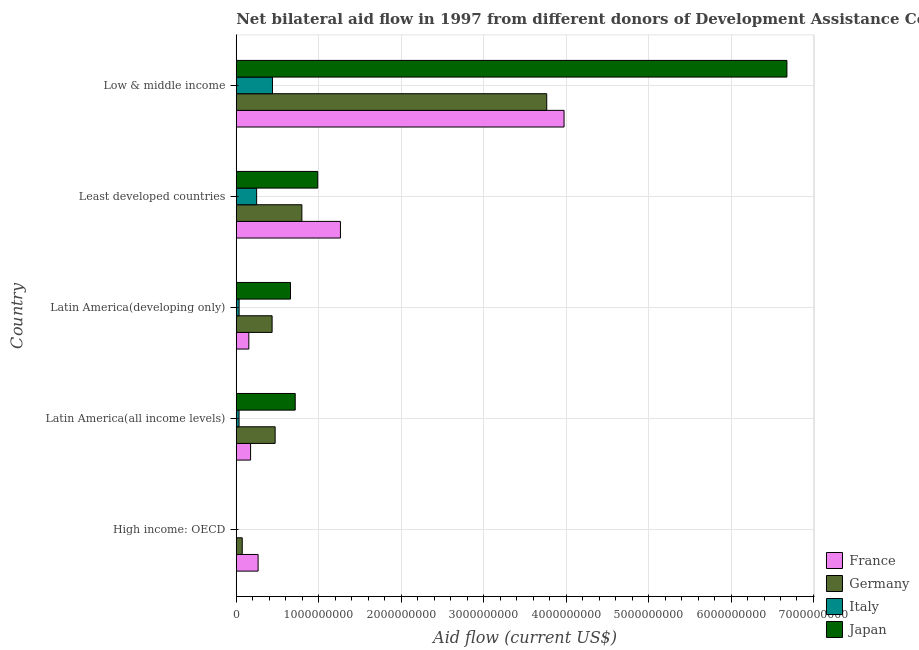How many groups of bars are there?
Keep it short and to the point. 5. Are the number of bars per tick equal to the number of legend labels?
Provide a succinct answer. No. How many bars are there on the 3rd tick from the top?
Give a very brief answer. 4. How many bars are there on the 2nd tick from the bottom?
Your answer should be compact. 4. What is the label of the 4th group of bars from the top?
Offer a very short reply. Latin America(all income levels). In how many cases, is the number of bars for a given country not equal to the number of legend labels?
Provide a short and direct response. 1. What is the amount of aid given by germany in Latin America(all income levels)?
Your response must be concise. 4.72e+08. Across all countries, what is the maximum amount of aid given by japan?
Provide a succinct answer. 6.68e+09. In which country was the amount of aid given by france maximum?
Your answer should be compact. Low & middle income. What is the total amount of aid given by france in the graph?
Provide a succinct answer. 5.83e+09. What is the difference between the amount of aid given by japan in Latin America(developing only) and that in Low & middle income?
Make the answer very short. -6.02e+09. What is the difference between the amount of aid given by france in Least developed countries and the amount of aid given by italy in High income: OECD?
Provide a succinct answer. 1.26e+09. What is the average amount of aid given by italy per country?
Your answer should be compact. 1.51e+08. What is the difference between the amount of aid given by italy and amount of aid given by japan in Latin America(all income levels)?
Offer a terse response. -6.81e+08. In how many countries, is the amount of aid given by germany greater than 5600000000 US$?
Your answer should be very brief. 0. What is the ratio of the amount of aid given by italy in Latin America(all income levels) to that in Low & middle income?
Provide a succinct answer. 0.08. Is the amount of aid given by france in Least developed countries less than that in Low & middle income?
Offer a terse response. Yes. Is the difference between the amount of aid given by japan in Least developed countries and Low & middle income greater than the difference between the amount of aid given by france in Least developed countries and Low & middle income?
Your answer should be very brief. No. What is the difference between the highest and the second highest amount of aid given by germany?
Your answer should be compact. 2.97e+09. What is the difference between the highest and the lowest amount of aid given by japan?
Ensure brevity in your answer.  6.68e+09. Is the sum of the amount of aid given by germany in Least developed countries and Low & middle income greater than the maximum amount of aid given by japan across all countries?
Make the answer very short. No. What is the difference between two consecutive major ticks on the X-axis?
Keep it short and to the point. 1.00e+09. Are the values on the major ticks of X-axis written in scientific E-notation?
Give a very brief answer. No. How are the legend labels stacked?
Make the answer very short. Vertical. What is the title of the graph?
Offer a terse response. Net bilateral aid flow in 1997 from different donors of Development Assistance Committee. What is the label or title of the Y-axis?
Provide a succinct answer. Country. What is the Aid flow (current US$) in France in High income: OECD?
Your answer should be very brief. 2.65e+08. What is the Aid flow (current US$) of Germany in High income: OECD?
Provide a succinct answer. 7.26e+07. What is the Aid flow (current US$) in Italy in High income: OECD?
Give a very brief answer. 1.71e+06. What is the Aid flow (current US$) of France in Latin America(all income levels)?
Your answer should be very brief. 1.74e+08. What is the Aid flow (current US$) of Germany in Latin America(all income levels)?
Provide a succinct answer. 4.72e+08. What is the Aid flow (current US$) of Italy in Latin America(all income levels)?
Offer a terse response. 3.40e+07. What is the Aid flow (current US$) in Japan in Latin America(all income levels)?
Ensure brevity in your answer.  7.15e+08. What is the Aid flow (current US$) in France in Latin America(developing only)?
Offer a very short reply. 1.52e+08. What is the Aid flow (current US$) in Germany in Latin America(developing only)?
Make the answer very short. 4.35e+08. What is the Aid flow (current US$) in Italy in Latin America(developing only)?
Your response must be concise. 3.46e+07. What is the Aid flow (current US$) in Japan in Latin America(developing only)?
Provide a short and direct response. 6.58e+08. What is the Aid flow (current US$) of France in Least developed countries?
Your answer should be compact. 1.26e+09. What is the Aid flow (current US$) of Germany in Least developed countries?
Make the answer very short. 7.96e+08. What is the Aid flow (current US$) of Italy in Least developed countries?
Offer a very short reply. 2.47e+08. What is the Aid flow (current US$) of Japan in Least developed countries?
Your answer should be compact. 9.88e+08. What is the Aid flow (current US$) in France in Low & middle income?
Offer a very short reply. 3.98e+09. What is the Aid flow (current US$) in Germany in Low & middle income?
Your response must be concise. 3.77e+09. What is the Aid flow (current US$) in Italy in Low & middle income?
Your response must be concise. 4.39e+08. What is the Aid flow (current US$) of Japan in Low & middle income?
Offer a very short reply. 6.68e+09. Across all countries, what is the maximum Aid flow (current US$) in France?
Offer a terse response. 3.98e+09. Across all countries, what is the maximum Aid flow (current US$) in Germany?
Ensure brevity in your answer.  3.77e+09. Across all countries, what is the maximum Aid flow (current US$) of Italy?
Provide a succinct answer. 4.39e+08. Across all countries, what is the maximum Aid flow (current US$) of Japan?
Provide a succinct answer. 6.68e+09. Across all countries, what is the minimum Aid flow (current US$) in France?
Your answer should be compact. 1.52e+08. Across all countries, what is the minimum Aid flow (current US$) of Germany?
Provide a short and direct response. 7.26e+07. Across all countries, what is the minimum Aid flow (current US$) in Italy?
Ensure brevity in your answer.  1.71e+06. Across all countries, what is the minimum Aid flow (current US$) in Japan?
Give a very brief answer. 0. What is the total Aid flow (current US$) of France in the graph?
Your response must be concise. 5.83e+09. What is the total Aid flow (current US$) in Germany in the graph?
Your response must be concise. 5.54e+09. What is the total Aid flow (current US$) of Italy in the graph?
Offer a very short reply. 7.57e+08. What is the total Aid flow (current US$) of Japan in the graph?
Provide a succinct answer. 9.04e+09. What is the difference between the Aid flow (current US$) in France in High income: OECD and that in Latin America(all income levels)?
Provide a succinct answer. 9.13e+07. What is the difference between the Aid flow (current US$) in Germany in High income: OECD and that in Latin America(all income levels)?
Make the answer very short. -3.99e+08. What is the difference between the Aid flow (current US$) of Italy in High income: OECD and that in Latin America(all income levels)?
Offer a terse response. -3.23e+07. What is the difference between the Aid flow (current US$) in France in High income: OECD and that in Latin America(developing only)?
Provide a short and direct response. 1.13e+08. What is the difference between the Aid flow (current US$) of Germany in High income: OECD and that in Latin America(developing only)?
Offer a terse response. -3.62e+08. What is the difference between the Aid flow (current US$) of Italy in High income: OECD and that in Latin America(developing only)?
Ensure brevity in your answer.  -3.29e+07. What is the difference between the Aid flow (current US$) of France in High income: OECD and that in Least developed countries?
Keep it short and to the point. -9.99e+08. What is the difference between the Aid flow (current US$) in Germany in High income: OECD and that in Least developed countries?
Give a very brief answer. -7.23e+08. What is the difference between the Aid flow (current US$) of Italy in High income: OECD and that in Least developed countries?
Offer a terse response. -2.46e+08. What is the difference between the Aid flow (current US$) in France in High income: OECD and that in Low & middle income?
Your answer should be compact. -3.71e+09. What is the difference between the Aid flow (current US$) of Germany in High income: OECD and that in Low & middle income?
Give a very brief answer. -3.69e+09. What is the difference between the Aid flow (current US$) of Italy in High income: OECD and that in Low & middle income?
Provide a succinct answer. -4.38e+08. What is the difference between the Aid flow (current US$) of France in Latin America(all income levels) and that in Latin America(developing only)?
Ensure brevity in your answer.  2.13e+07. What is the difference between the Aid flow (current US$) in Germany in Latin America(all income levels) and that in Latin America(developing only)?
Give a very brief answer. 3.68e+07. What is the difference between the Aid flow (current US$) of Italy in Latin America(all income levels) and that in Latin America(developing only)?
Offer a very short reply. -6.20e+05. What is the difference between the Aid flow (current US$) in Japan in Latin America(all income levels) and that in Latin America(developing only)?
Provide a short and direct response. 5.74e+07. What is the difference between the Aid flow (current US$) in France in Latin America(all income levels) and that in Least developed countries?
Provide a short and direct response. -1.09e+09. What is the difference between the Aid flow (current US$) in Germany in Latin America(all income levels) and that in Least developed countries?
Your response must be concise. -3.24e+08. What is the difference between the Aid flow (current US$) of Italy in Latin America(all income levels) and that in Least developed countries?
Keep it short and to the point. -2.13e+08. What is the difference between the Aid flow (current US$) of Japan in Latin America(all income levels) and that in Least developed countries?
Provide a succinct answer. -2.73e+08. What is the difference between the Aid flow (current US$) of France in Latin America(all income levels) and that in Low & middle income?
Ensure brevity in your answer.  -3.80e+09. What is the difference between the Aid flow (current US$) in Germany in Latin America(all income levels) and that in Low & middle income?
Make the answer very short. -3.29e+09. What is the difference between the Aid flow (current US$) of Italy in Latin America(all income levels) and that in Low & middle income?
Make the answer very short. -4.05e+08. What is the difference between the Aid flow (current US$) in Japan in Latin America(all income levels) and that in Low & middle income?
Keep it short and to the point. -5.96e+09. What is the difference between the Aid flow (current US$) of France in Latin America(developing only) and that in Least developed countries?
Make the answer very short. -1.11e+09. What is the difference between the Aid flow (current US$) in Germany in Latin America(developing only) and that in Least developed countries?
Give a very brief answer. -3.61e+08. What is the difference between the Aid flow (current US$) in Italy in Latin America(developing only) and that in Least developed countries?
Offer a terse response. -2.13e+08. What is the difference between the Aid flow (current US$) of Japan in Latin America(developing only) and that in Least developed countries?
Give a very brief answer. -3.31e+08. What is the difference between the Aid flow (current US$) of France in Latin America(developing only) and that in Low & middle income?
Offer a very short reply. -3.82e+09. What is the difference between the Aid flow (current US$) of Germany in Latin America(developing only) and that in Low & middle income?
Ensure brevity in your answer.  -3.33e+09. What is the difference between the Aid flow (current US$) of Italy in Latin America(developing only) and that in Low & middle income?
Offer a very short reply. -4.05e+08. What is the difference between the Aid flow (current US$) in Japan in Latin America(developing only) and that in Low & middle income?
Offer a terse response. -6.02e+09. What is the difference between the Aid flow (current US$) in France in Least developed countries and that in Low & middle income?
Ensure brevity in your answer.  -2.71e+09. What is the difference between the Aid flow (current US$) in Germany in Least developed countries and that in Low & middle income?
Make the answer very short. -2.97e+09. What is the difference between the Aid flow (current US$) of Italy in Least developed countries and that in Low & middle income?
Offer a terse response. -1.92e+08. What is the difference between the Aid flow (current US$) in Japan in Least developed countries and that in Low & middle income?
Keep it short and to the point. -5.69e+09. What is the difference between the Aid flow (current US$) of France in High income: OECD and the Aid flow (current US$) of Germany in Latin America(all income levels)?
Provide a succinct answer. -2.07e+08. What is the difference between the Aid flow (current US$) in France in High income: OECD and the Aid flow (current US$) in Italy in Latin America(all income levels)?
Offer a terse response. 2.31e+08. What is the difference between the Aid flow (current US$) of France in High income: OECD and the Aid flow (current US$) of Japan in Latin America(all income levels)?
Provide a short and direct response. -4.50e+08. What is the difference between the Aid flow (current US$) in Germany in High income: OECD and the Aid flow (current US$) in Italy in Latin America(all income levels)?
Ensure brevity in your answer.  3.86e+07. What is the difference between the Aid flow (current US$) of Germany in High income: OECD and the Aid flow (current US$) of Japan in Latin America(all income levels)?
Provide a short and direct response. -6.42e+08. What is the difference between the Aid flow (current US$) of Italy in High income: OECD and the Aid flow (current US$) of Japan in Latin America(all income levels)?
Your response must be concise. -7.13e+08. What is the difference between the Aid flow (current US$) of France in High income: OECD and the Aid flow (current US$) of Germany in Latin America(developing only)?
Make the answer very short. -1.70e+08. What is the difference between the Aid flow (current US$) in France in High income: OECD and the Aid flow (current US$) in Italy in Latin America(developing only)?
Make the answer very short. 2.30e+08. What is the difference between the Aid flow (current US$) of France in High income: OECD and the Aid flow (current US$) of Japan in Latin America(developing only)?
Offer a very short reply. -3.93e+08. What is the difference between the Aid flow (current US$) of Germany in High income: OECD and the Aid flow (current US$) of Italy in Latin America(developing only)?
Provide a short and direct response. 3.80e+07. What is the difference between the Aid flow (current US$) in Germany in High income: OECD and the Aid flow (current US$) in Japan in Latin America(developing only)?
Make the answer very short. -5.85e+08. What is the difference between the Aid flow (current US$) in Italy in High income: OECD and the Aid flow (current US$) in Japan in Latin America(developing only)?
Your answer should be compact. -6.56e+08. What is the difference between the Aid flow (current US$) in France in High income: OECD and the Aid flow (current US$) in Germany in Least developed countries?
Give a very brief answer. -5.31e+08. What is the difference between the Aid flow (current US$) in France in High income: OECD and the Aid flow (current US$) in Italy in Least developed countries?
Provide a short and direct response. 1.78e+07. What is the difference between the Aid flow (current US$) in France in High income: OECD and the Aid flow (current US$) in Japan in Least developed countries?
Offer a terse response. -7.23e+08. What is the difference between the Aid flow (current US$) in Germany in High income: OECD and the Aid flow (current US$) in Italy in Least developed countries?
Your answer should be very brief. -1.75e+08. What is the difference between the Aid flow (current US$) of Germany in High income: OECD and the Aid flow (current US$) of Japan in Least developed countries?
Ensure brevity in your answer.  -9.16e+08. What is the difference between the Aid flow (current US$) of Italy in High income: OECD and the Aid flow (current US$) of Japan in Least developed countries?
Provide a succinct answer. -9.87e+08. What is the difference between the Aid flow (current US$) in France in High income: OECD and the Aid flow (current US$) in Germany in Low & middle income?
Keep it short and to the point. -3.50e+09. What is the difference between the Aid flow (current US$) in France in High income: OECD and the Aid flow (current US$) in Italy in Low & middle income?
Provide a succinct answer. -1.74e+08. What is the difference between the Aid flow (current US$) in France in High income: OECD and the Aid flow (current US$) in Japan in Low & middle income?
Keep it short and to the point. -6.41e+09. What is the difference between the Aid flow (current US$) in Germany in High income: OECD and the Aid flow (current US$) in Italy in Low & middle income?
Make the answer very short. -3.67e+08. What is the difference between the Aid flow (current US$) of Germany in High income: OECD and the Aid flow (current US$) of Japan in Low & middle income?
Offer a terse response. -6.61e+09. What is the difference between the Aid flow (current US$) in Italy in High income: OECD and the Aid flow (current US$) in Japan in Low & middle income?
Offer a very short reply. -6.68e+09. What is the difference between the Aid flow (current US$) in France in Latin America(all income levels) and the Aid flow (current US$) in Germany in Latin America(developing only)?
Your answer should be compact. -2.61e+08. What is the difference between the Aid flow (current US$) in France in Latin America(all income levels) and the Aid flow (current US$) in Italy in Latin America(developing only)?
Provide a succinct answer. 1.39e+08. What is the difference between the Aid flow (current US$) in France in Latin America(all income levels) and the Aid flow (current US$) in Japan in Latin America(developing only)?
Your answer should be very brief. -4.84e+08. What is the difference between the Aid flow (current US$) in Germany in Latin America(all income levels) and the Aid flow (current US$) in Italy in Latin America(developing only)?
Provide a succinct answer. 4.37e+08. What is the difference between the Aid flow (current US$) of Germany in Latin America(all income levels) and the Aid flow (current US$) of Japan in Latin America(developing only)?
Give a very brief answer. -1.86e+08. What is the difference between the Aid flow (current US$) in Italy in Latin America(all income levels) and the Aid flow (current US$) in Japan in Latin America(developing only)?
Ensure brevity in your answer.  -6.24e+08. What is the difference between the Aid flow (current US$) of France in Latin America(all income levels) and the Aid flow (current US$) of Germany in Least developed countries?
Give a very brief answer. -6.22e+08. What is the difference between the Aid flow (current US$) in France in Latin America(all income levels) and the Aid flow (current US$) in Italy in Least developed countries?
Your answer should be compact. -7.36e+07. What is the difference between the Aid flow (current US$) in France in Latin America(all income levels) and the Aid flow (current US$) in Japan in Least developed countries?
Your answer should be compact. -8.15e+08. What is the difference between the Aid flow (current US$) in Germany in Latin America(all income levels) and the Aid flow (current US$) in Italy in Least developed countries?
Provide a short and direct response. 2.24e+08. What is the difference between the Aid flow (current US$) of Germany in Latin America(all income levels) and the Aid flow (current US$) of Japan in Least developed countries?
Your response must be concise. -5.17e+08. What is the difference between the Aid flow (current US$) of Italy in Latin America(all income levels) and the Aid flow (current US$) of Japan in Least developed countries?
Keep it short and to the point. -9.54e+08. What is the difference between the Aid flow (current US$) of France in Latin America(all income levels) and the Aid flow (current US$) of Germany in Low & middle income?
Keep it short and to the point. -3.59e+09. What is the difference between the Aid flow (current US$) in France in Latin America(all income levels) and the Aid flow (current US$) in Italy in Low & middle income?
Offer a very short reply. -2.66e+08. What is the difference between the Aid flow (current US$) in France in Latin America(all income levels) and the Aid flow (current US$) in Japan in Low & middle income?
Offer a very short reply. -6.50e+09. What is the difference between the Aid flow (current US$) of Germany in Latin America(all income levels) and the Aid flow (current US$) of Italy in Low & middle income?
Make the answer very short. 3.23e+07. What is the difference between the Aid flow (current US$) in Germany in Latin America(all income levels) and the Aid flow (current US$) in Japan in Low & middle income?
Offer a terse response. -6.21e+09. What is the difference between the Aid flow (current US$) of Italy in Latin America(all income levels) and the Aid flow (current US$) of Japan in Low & middle income?
Your response must be concise. -6.64e+09. What is the difference between the Aid flow (current US$) of France in Latin America(developing only) and the Aid flow (current US$) of Germany in Least developed countries?
Offer a terse response. -6.43e+08. What is the difference between the Aid flow (current US$) of France in Latin America(developing only) and the Aid flow (current US$) of Italy in Least developed countries?
Provide a short and direct response. -9.48e+07. What is the difference between the Aid flow (current US$) in France in Latin America(developing only) and the Aid flow (current US$) in Japan in Least developed countries?
Provide a succinct answer. -8.36e+08. What is the difference between the Aid flow (current US$) of Germany in Latin America(developing only) and the Aid flow (current US$) of Italy in Least developed countries?
Ensure brevity in your answer.  1.88e+08. What is the difference between the Aid flow (current US$) of Germany in Latin America(developing only) and the Aid flow (current US$) of Japan in Least developed countries?
Your answer should be very brief. -5.54e+08. What is the difference between the Aid flow (current US$) in Italy in Latin America(developing only) and the Aid flow (current US$) in Japan in Least developed countries?
Offer a very short reply. -9.54e+08. What is the difference between the Aid flow (current US$) in France in Latin America(developing only) and the Aid flow (current US$) in Germany in Low & middle income?
Your response must be concise. -3.61e+09. What is the difference between the Aid flow (current US$) in France in Latin America(developing only) and the Aid flow (current US$) in Italy in Low & middle income?
Keep it short and to the point. -2.87e+08. What is the difference between the Aid flow (current US$) of France in Latin America(developing only) and the Aid flow (current US$) of Japan in Low & middle income?
Offer a terse response. -6.53e+09. What is the difference between the Aid flow (current US$) of Germany in Latin America(developing only) and the Aid flow (current US$) of Italy in Low & middle income?
Provide a succinct answer. -4.52e+06. What is the difference between the Aid flow (current US$) in Germany in Latin America(developing only) and the Aid flow (current US$) in Japan in Low & middle income?
Provide a short and direct response. -6.24e+09. What is the difference between the Aid flow (current US$) of Italy in Latin America(developing only) and the Aid flow (current US$) of Japan in Low & middle income?
Offer a terse response. -6.64e+09. What is the difference between the Aid flow (current US$) in France in Least developed countries and the Aid flow (current US$) in Germany in Low & middle income?
Your response must be concise. -2.50e+09. What is the difference between the Aid flow (current US$) of France in Least developed countries and the Aid flow (current US$) of Italy in Low & middle income?
Provide a short and direct response. 8.24e+08. What is the difference between the Aid flow (current US$) in France in Least developed countries and the Aid flow (current US$) in Japan in Low & middle income?
Offer a very short reply. -5.41e+09. What is the difference between the Aid flow (current US$) of Germany in Least developed countries and the Aid flow (current US$) of Italy in Low & middle income?
Offer a terse response. 3.57e+08. What is the difference between the Aid flow (current US$) in Germany in Least developed countries and the Aid flow (current US$) in Japan in Low & middle income?
Your response must be concise. -5.88e+09. What is the difference between the Aid flow (current US$) of Italy in Least developed countries and the Aid flow (current US$) of Japan in Low & middle income?
Offer a terse response. -6.43e+09. What is the average Aid flow (current US$) of France per country?
Your response must be concise. 1.17e+09. What is the average Aid flow (current US$) in Germany per country?
Offer a terse response. 1.11e+09. What is the average Aid flow (current US$) in Italy per country?
Your response must be concise. 1.51e+08. What is the average Aid flow (current US$) in Japan per country?
Provide a short and direct response. 1.81e+09. What is the difference between the Aid flow (current US$) of France and Aid flow (current US$) of Germany in High income: OECD?
Offer a terse response. 1.92e+08. What is the difference between the Aid flow (current US$) of France and Aid flow (current US$) of Italy in High income: OECD?
Provide a succinct answer. 2.63e+08. What is the difference between the Aid flow (current US$) in Germany and Aid flow (current US$) in Italy in High income: OECD?
Your answer should be very brief. 7.09e+07. What is the difference between the Aid flow (current US$) in France and Aid flow (current US$) in Germany in Latin America(all income levels)?
Provide a succinct answer. -2.98e+08. What is the difference between the Aid flow (current US$) of France and Aid flow (current US$) of Italy in Latin America(all income levels)?
Your answer should be very brief. 1.40e+08. What is the difference between the Aid flow (current US$) in France and Aid flow (current US$) in Japan in Latin America(all income levels)?
Your answer should be very brief. -5.41e+08. What is the difference between the Aid flow (current US$) in Germany and Aid flow (current US$) in Italy in Latin America(all income levels)?
Give a very brief answer. 4.38e+08. What is the difference between the Aid flow (current US$) in Germany and Aid flow (current US$) in Japan in Latin America(all income levels)?
Your answer should be compact. -2.44e+08. What is the difference between the Aid flow (current US$) of Italy and Aid flow (current US$) of Japan in Latin America(all income levels)?
Give a very brief answer. -6.81e+08. What is the difference between the Aid flow (current US$) in France and Aid flow (current US$) in Germany in Latin America(developing only)?
Give a very brief answer. -2.82e+08. What is the difference between the Aid flow (current US$) of France and Aid flow (current US$) of Italy in Latin America(developing only)?
Offer a very short reply. 1.18e+08. What is the difference between the Aid flow (current US$) of France and Aid flow (current US$) of Japan in Latin America(developing only)?
Offer a very short reply. -5.05e+08. What is the difference between the Aid flow (current US$) of Germany and Aid flow (current US$) of Italy in Latin America(developing only)?
Your answer should be very brief. 4.00e+08. What is the difference between the Aid flow (current US$) in Germany and Aid flow (current US$) in Japan in Latin America(developing only)?
Ensure brevity in your answer.  -2.23e+08. What is the difference between the Aid flow (current US$) of Italy and Aid flow (current US$) of Japan in Latin America(developing only)?
Give a very brief answer. -6.23e+08. What is the difference between the Aid flow (current US$) of France and Aid flow (current US$) of Germany in Least developed countries?
Keep it short and to the point. 4.68e+08. What is the difference between the Aid flow (current US$) in France and Aid flow (current US$) in Italy in Least developed countries?
Ensure brevity in your answer.  1.02e+09. What is the difference between the Aid flow (current US$) in France and Aid flow (current US$) in Japan in Least developed countries?
Provide a short and direct response. 2.75e+08. What is the difference between the Aid flow (current US$) in Germany and Aid flow (current US$) in Italy in Least developed countries?
Give a very brief answer. 5.49e+08. What is the difference between the Aid flow (current US$) in Germany and Aid flow (current US$) in Japan in Least developed countries?
Ensure brevity in your answer.  -1.93e+08. What is the difference between the Aid flow (current US$) of Italy and Aid flow (current US$) of Japan in Least developed countries?
Provide a short and direct response. -7.41e+08. What is the difference between the Aid flow (current US$) of France and Aid flow (current US$) of Germany in Low & middle income?
Provide a short and direct response. 2.10e+08. What is the difference between the Aid flow (current US$) of France and Aid flow (current US$) of Italy in Low & middle income?
Offer a very short reply. 3.54e+09. What is the difference between the Aid flow (current US$) of France and Aid flow (current US$) of Japan in Low & middle income?
Provide a succinct answer. -2.70e+09. What is the difference between the Aid flow (current US$) of Germany and Aid flow (current US$) of Italy in Low & middle income?
Ensure brevity in your answer.  3.33e+09. What is the difference between the Aid flow (current US$) of Germany and Aid flow (current US$) of Japan in Low & middle income?
Keep it short and to the point. -2.91e+09. What is the difference between the Aid flow (current US$) of Italy and Aid flow (current US$) of Japan in Low & middle income?
Ensure brevity in your answer.  -6.24e+09. What is the ratio of the Aid flow (current US$) in France in High income: OECD to that in Latin America(all income levels)?
Your answer should be compact. 1.53. What is the ratio of the Aid flow (current US$) of Germany in High income: OECD to that in Latin America(all income levels)?
Offer a terse response. 0.15. What is the ratio of the Aid flow (current US$) in Italy in High income: OECD to that in Latin America(all income levels)?
Offer a very short reply. 0.05. What is the ratio of the Aid flow (current US$) in France in High income: OECD to that in Latin America(developing only)?
Your response must be concise. 1.74. What is the ratio of the Aid flow (current US$) in Germany in High income: OECD to that in Latin America(developing only)?
Provide a short and direct response. 0.17. What is the ratio of the Aid flow (current US$) of Italy in High income: OECD to that in Latin America(developing only)?
Your answer should be compact. 0.05. What is the ratio of the Aid flow (current US$) of France in High income: OECD to that in Least developed countries?
Provide a short and direct response. 0.21. What is the ratio of the Aid flow (current US$) in Germany in High income: OECD to that in Least developed countries?
Provide a succinct answer. 0.09. What is the ratio of the Aid flow (current US$) of Italy in High income: OECD to that in Least developed countries?
Provide a short and direct response. 0.01. What is the ratio of the Aid flow (current US$) in France in High income: OECD to that in Low & middle income?
Give a very brief answer. 0.07. What is the ratio of the Aid flow (current US$) in Germany in High income: OECD to that in Low & middle income?
Offer a terse response. 0.02. What is the ratio of the Aid flow (current US$) of Italy in High income: OECD to that in Low & middle income?
Make the answer very short. 0. What is the ratio of the Aid flow (current US$) in France in Latin America(all income levels) to that in Latin America(developing only)?
Offer a terse response. 1.14. What is the ratio of the Aid flow (current US$) in Germany in Latin America(all income levels) to that in Latin America(developing only)?
Make the answer very short. 1.08. What is the ratio of the Aid flow (current US$) in Italy in Latin America(all income levels) to that in Latin America(developing only)?
Offer a very short reply. 0.98. What is the ratio of the Aid flow (current US$) in Japan in Latin America(all income levels) to that in Latin America(developing only)?
Give a very brief answer. 1.09. What is the ratio of the Aid flow (current US$) in France in Latin America(all income levels) to that in Least developed countries?
Provide a succinct answer. 0.14. What is the ratio of the Aid flow (current US$) of Germany in Latin America(all income levels) to that in Least developed countries?
Provide a short and direct response. 0.59. What is the ratio of the Aid flow (current US$) of Italy in Latin America(all income levels) to that in Least developed countries?
Your response must be concise. 0.14. What is the ratio of the Aid flow (current US$) in Japan in Latin America(all income levels) to that in Least developed countries?
Your answer should be very brief. 0.72. What is the ratio of the Aid flow (current US$) of France in Latin America(all income levels) to that in Low & middle income?
Your response must be concise. 0.04. What is the ratio of the Aid flow (current US$) in Germany in Latin America(all income levels) to that in Low & middle income?
Your answer should be very brief. 0.13. What is the ratio of the Aid flow (current US$) of Italy in Latin America(all income levels) to that in Low & middle income?
Your answer should be compact. 0.08. What is the ratio of the Aid flow (current US$) of Japan in Latin America(all income levels) to that in Low & middle income?
Ensure brevity in your answer.  0.11. What is the ratio of the Aid flow (current US$) of France in Latin America(developing only) to that in Least developed countries?
Your answer should be compact. 0.12. What is the ratio of the Aid flow (current US$) in Germany in Latin America(developing only) to that in Least developed countries?
Your response must be concise. 0.55. What is the ratio of the Aid flow (current US$) of Italy in Latin America(developing only) to that in Least developed countries?
Give a very brief answer. 0.14. What is the ratio of the Aid flow (current US$) in Japan in Latin America(developing only) to that in Least developed countries?
Give a very brief answer. 0.67. What is the ratio of the Aid flow (current US$) of France in Latin America(developing only) to that in Low & middle income?
Keep it short and to the point. 0.04. What is the ratio of the Aid flow (current US$) in Germany in Latin America(developing only) to that in Low & middle income?
Your answer should be very brief. 0.12. What is the ratio of the Aid flow (current US$) in Italy in Latin America(developing only) to that in Low & middle income?
Provide a short and direct response. 0.08. What is the ratio of the Aid flow (current US$) of Japan in Latin America(developing only) to that in Low & middle income?
Your response must be concise. 0.1. What is the ratio of the Aid flow (current US$) in France in Least developed countries to that in Low & middle income?
Your response must be concise. 0.32. What is the ratio of the Aid flow (current US$) in Germany in Least developed countries to that in Low & middle income?
Provide a succinct answer. 0.21. What is the ratio of the Aid flow (current US$) in Italy in Least developed countries to that in Low & middle income?
Your answer should be very brief. 0.56. What is the ratio of the Aid flow (current US$) in Japan in Least developed countries to that in Low & middle income?
Make the answer very short. 0.15. What is the difference between the highest and the second highest Aid flow (current US$) of France?
Give a very brief answer. 2.71e+09. What is the difference between the highest and the second highest Aid flow (current US$) of Germany?
Your answer should be compact. 2.97e+09. What is the difference between the highest and the second highest Aid flow (current US$) of Italy?
Offer a terse response. 1.92e+08. What is the difference between the highest and the second highest Aid flow (current US$) in Japan?
Make the answer very short. 5.69e+09. What is the difference between the highest and the lowest Aid flow (current US$) in France?
Ensure brevity in your answer.  3.82e+09. What is the difference between the highest and the lowest Aid flow (current US$) of Germany?
Offer a very short reply. 3.69e+09. What is the difference between the highest and the lowest Aid flow (current US$) of Italy?
Your response must be concise. 4.38e+08. What is the difference between the highest and the lowest Aid flow (current US$) of Japan?
Provide a short and direct response. 6.68e+09. 